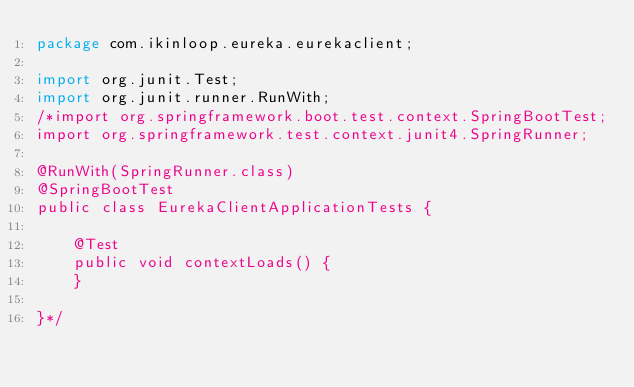Convert code to text. <code><loc_0><loc_0><loc_500><loc_500><_Java_>package com.ikinloop.eureka.eurekaclient;

import org.junit.Test;
import org.junit.runner.RunWith;
/*import org.springframework.boot.test.context.SpringBootTest;
import org.springframework.test.context.junit4.SpringRunner;

@RunWith(SpringRunner.class)
@SpringBootTest
public class EurekaClientApplicationTests {

    @Test
    public void contextLoads() {
    }

}*/
</code> 